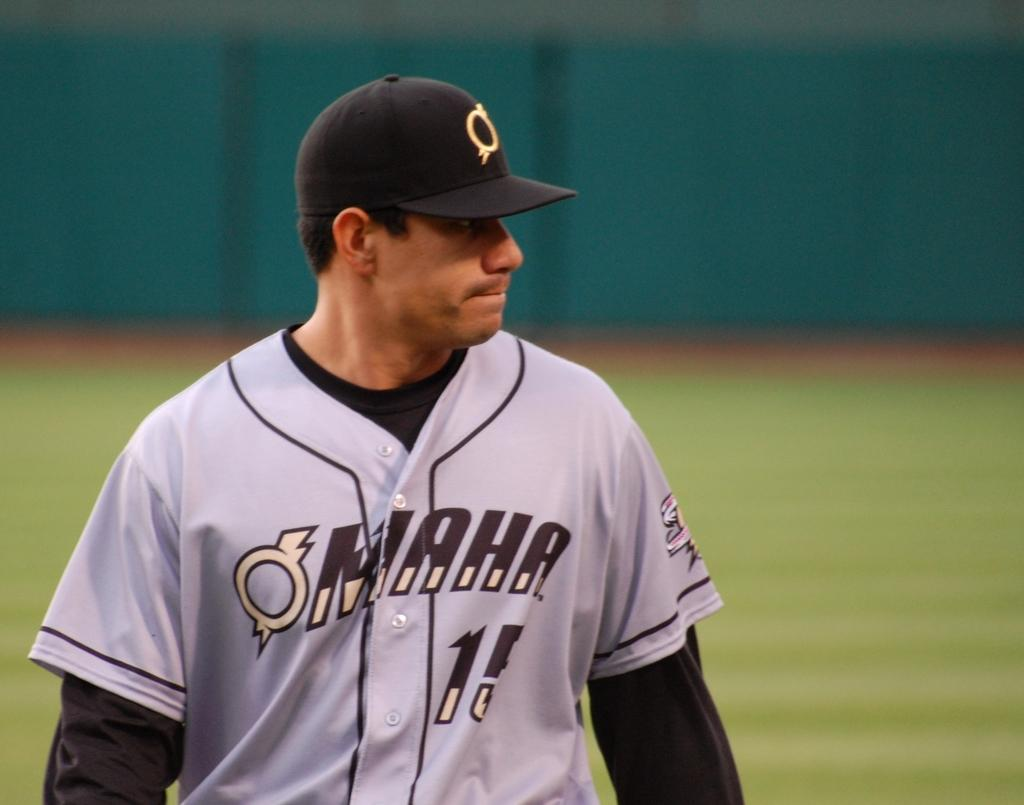Provide a one-sentence caption for the provided image. Player wearing a gray Omaha jersey walking on the field. 